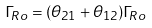<formula> <loc_0><loc_0><loc_500><loc_500>\Gamma _ { R o } = ( \theta _ { 2 1 } + \theta _ { 1 2 } ) \Gamma _ { R o }</formula> 